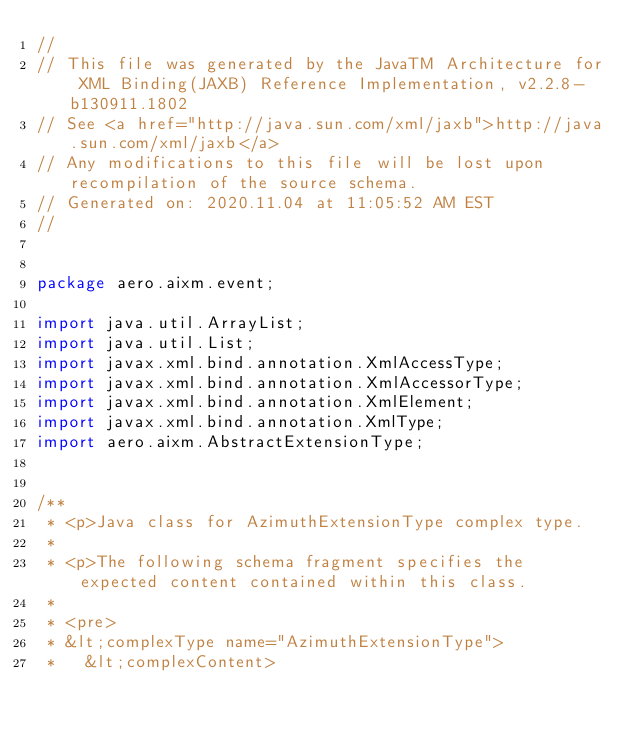<code> <loc_0><loc_0><loc_500><loc_500><_Java_>//
// This file was generated by the JavaTM Architecture for XML Binding(JAXB) Reference Implementation, v2.2.8-b130911.1802 
// See <a href="http://java.sun.com/xml/jaxb">http://java.sun.com/xml/jaxb</a> 
// Any modifications to this file will be lost upon recompilation of the source schema. 
// Generated on: 2020.11.04 at 11:05:52 AM EST 
//


package aero.aixm.event;

import java.util.ArrayList;
import java.util.List;
import javax.xml.bind.annotation.XmlAccessType;
import javax.xml.bind.annotation.XmlAccessorType;
import javax.xml.bind.annotation.XmlElement;
import javax.xml.bind.annotation.XmlType;
import aero.aixm.AbstractExtensionType;


/**
 * <p>Java class for AzimuthExtensionType complex type.
 * 
 * <p>The following schema fragment specifies the expected content contained within this class.
 * 
 * <pre>
 * &lt;complexType name="AzimuthExtensionType">
 *   &lt;complexContent></code> 